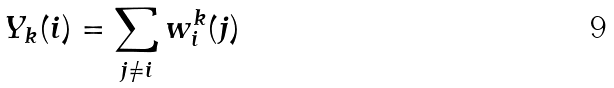Convert formula to latex. <formula><loc_0><loc_0><loc_500><loc_500>Y _ { k } ( i ) = \sum _ { j \neq i } w _ { i } ^ { k } ( j )</formula> 